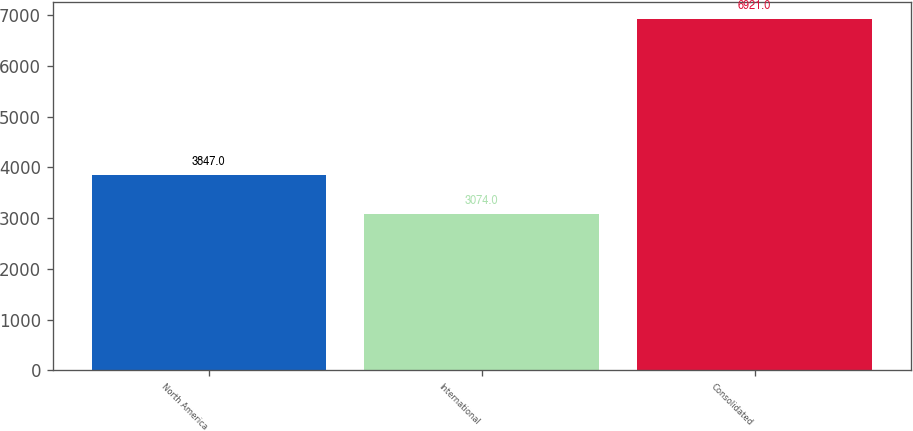<chart> <loc_0><loc_0><loc_500><loc_500><bar_chart><fcel>North America<fcel>International<fcel>Consolidated<nl><fcel>3847<fcel>3074<fcel>6921<nl></chart> 